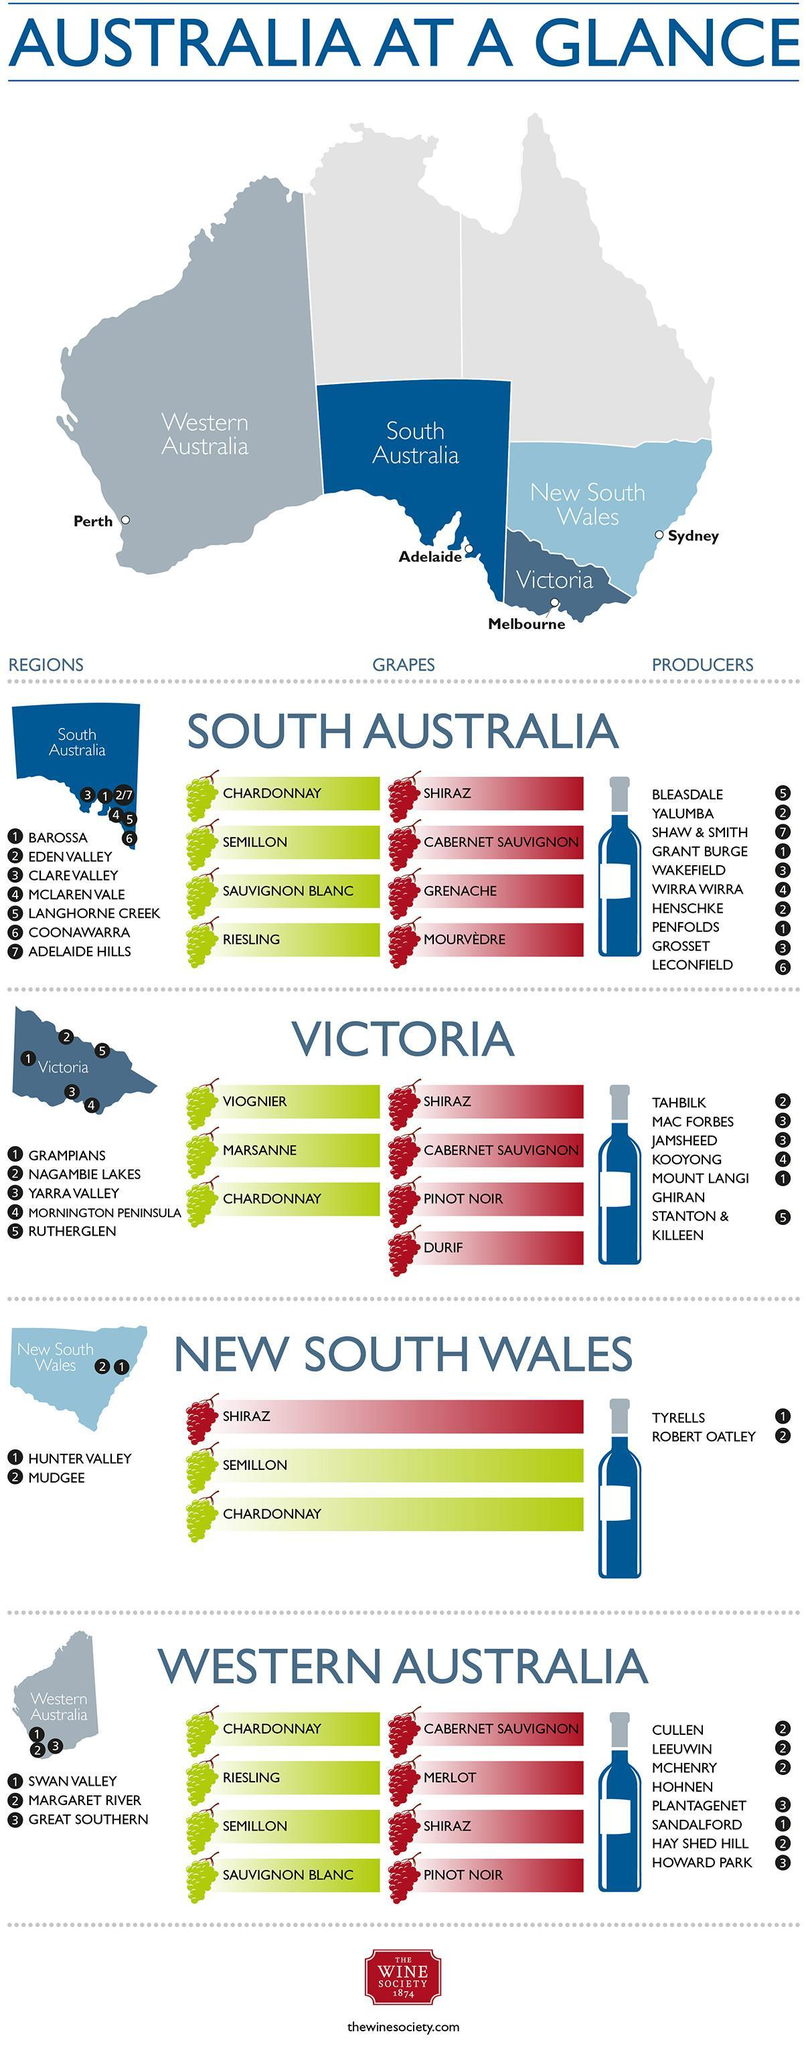Which wine company operates in the Coonawarra region of South Australia?
Answer the question with a short phrase. LECONFIELD Which winery operates in the Nagambie Lakes region of Victoria? TAHBILK In which state of Australia, 'Viognier ' wine grape variety is found? VICTORIA In which state of Australia, 'Grenache' wine grape variety is found? SOUTH AUSTRALIA Which wine company operates in the Mudgee region of New South Wales? ROBERT OATLEY Which winery operates in the Hunter Valley of New South Wales? TYRELLS In which states of Australia, 'Semillon ' wine grape variety is found? SOUTH AUSTRALIA, NEW SOUTH WALES, WESTERN AUSTRALIA 